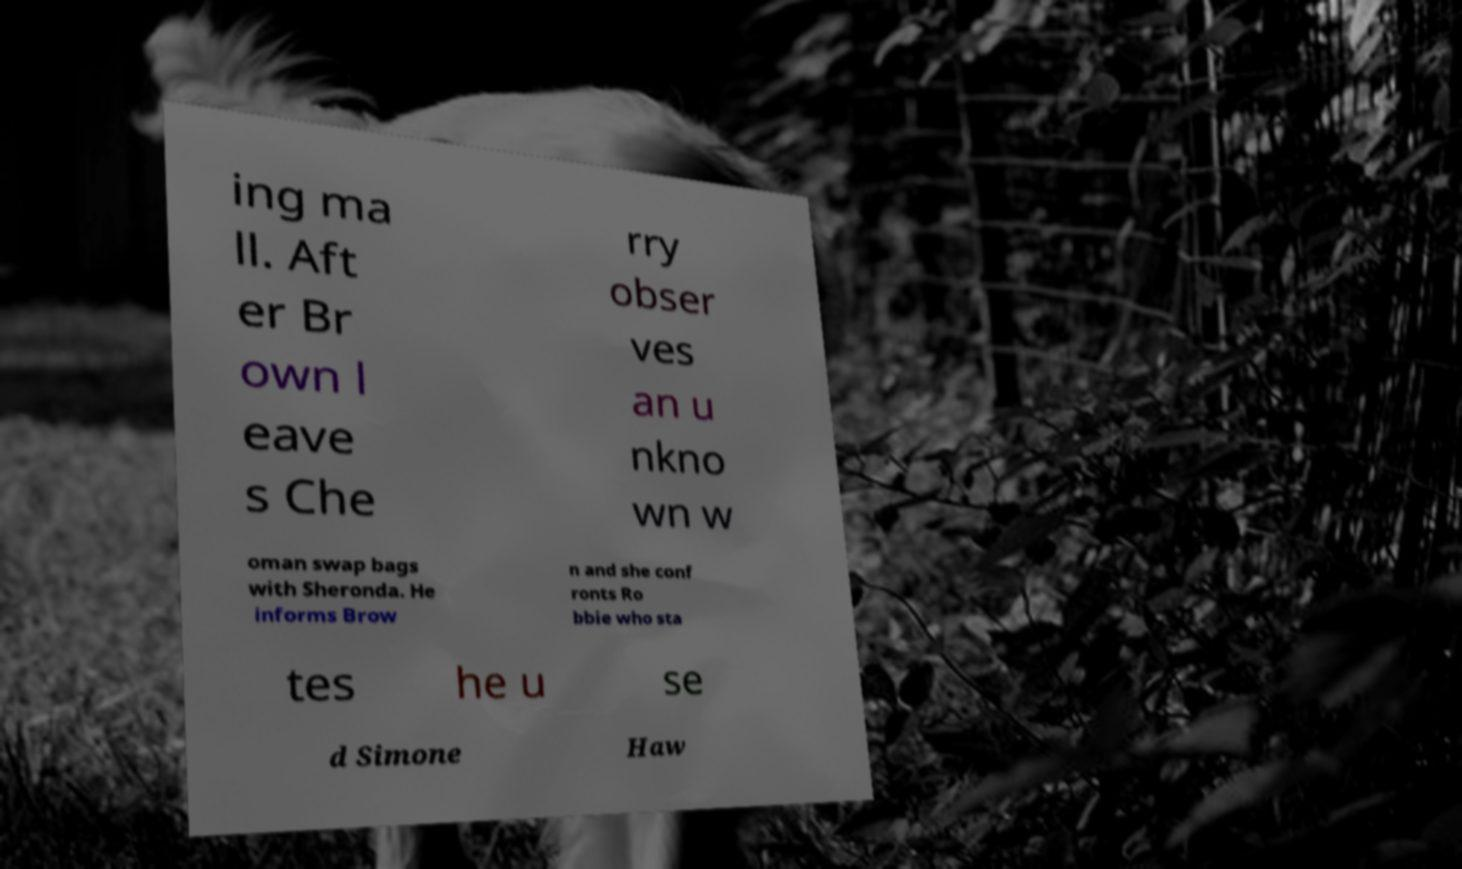Could you extract and type out the text from this image? ing ma ll. Aft er Br own l eave s Che rry obser ves an u nkno wn w oman swap bags with Sheronda. He informs Brow n and she conf ronts Ro bbie who sta tes he u se d Simone Haw 